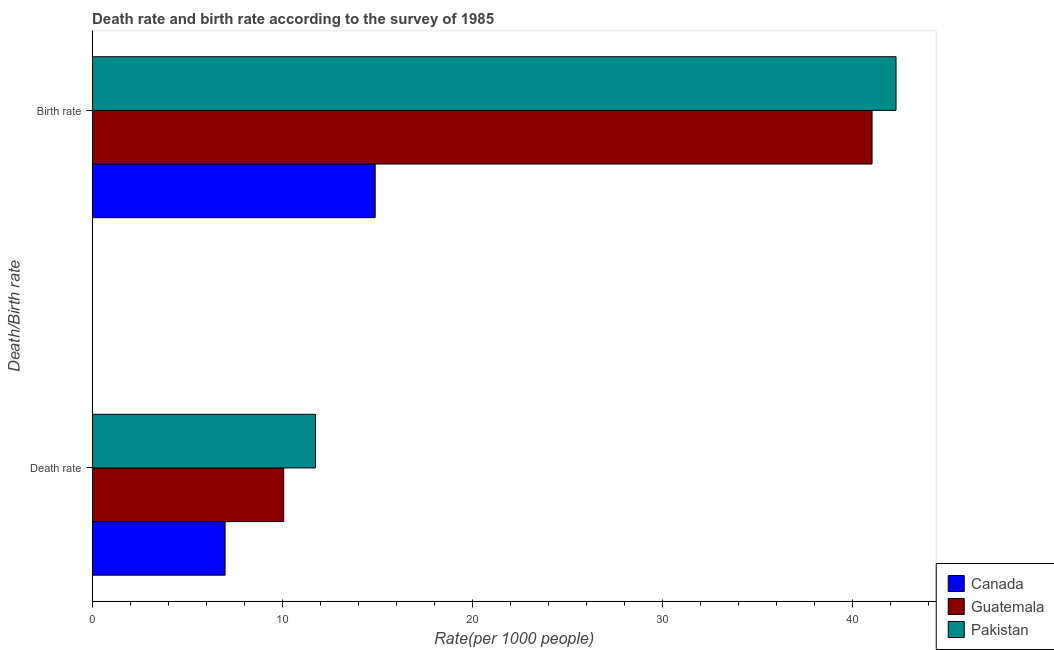How many groups of bars are there?
Keep it short and to the point. 2. Are the number of bars per tick equal to the number of legend labels?
Provide a short and direct response. Yes. Are the number of bars on each tick of the Y-axis equal?
Your answer should be compact. Yes. How many bars are there on the 2nd tick from the top?
Provide a succinct answer. 3. How many bars are there on the 2nd tick from the bottom?
Your response must be concise. 3. What is the label of the 1st group of bars from the top?
Keep it short and to the point. Birth rate. What is the death rate in Guatemala?
Ensure brevity in your answer.  10.09. Across all countries, what is the maximum death rate?
Your answer should be very brief. 11.76. Across all countries, what is the minimum birth rate?
Your response must be concise. 14.9. In which country was the death rate maximum?
Make the answer very short. Pakistan. What is the total death rate in the graph?
Your response must be concise. 28.84. What is the difference between the birth rate in Pakistan and that in Guatemala?
Your answer should be compact. 1.26. What is the difference between the death rate in Pakistan and the birth rate in Guatemala?
Give a very brief answer. -29.29. What is the average birth rate per country?
Give a very brief answer. 32.76. What is the difference between the birth rate and death rate in Pakistan?
Give a very brief answer. 30.56. In how many countries, is the death rate greater than 32 ?
Your answer should be compact. 0. What is the ratio of the birth rate in Guatemala to that in Pakistan?
Your answer should be compact. 0.97. Is the birth rate in Pakistan less than that in Guatemala?
Provide a succinct answer. No. What does the 1st bar from the bottom in Death rate represents?
Your answer should be very brief. Canada. How many bars are there?
Your answer should be compact. 6. Are all the bars in the graph horizontal?
Keep it short and to the point. Yes. What is the difference between two consecutive major ticks on the X-axis?
Give a very brief answer. 10. Are the values on the major ticks of X-axis written in scientific E-notation?
Make the answer very short. No. Does the graph contain any zero values?
Your response must be concise. No. Where does the legend appear in the graph?
Your response must be concise. Bottom right. How are the legend labels stacked?
Make the answer very short. Vertical. What is the title of the graph?
Ensure brevity in your answer.  Death rate and birth rate according to the survey of 1985. Does "Tunisia" appear as one of the legend labels in the graph?
Provide a short and direct response. No. What is the label or title of the X-axis?
Provide a succinct answer. Rate(per 1000 people). What is the label or title of the Y-axis?
Offer a terse response. Death/Birth rate. What is the Rate(per 1000 people) in Guatemala in Death rate?
Your answer should be very brief. 10.09. What is the Rate(per 1000 people) of Pakistan in Death rate?
Provide a succinct answer. 11.76. What is the Rate(per 1000 people) in Guatemala in Birth rate?
Your response must be concise. 41.05. What is the Rate(per 1000 people) in Pakistan in Birth rate?
Give a very brief answer. 42.31. Across all Death/Birth rate, what is the maximum Rate(per 1000 people) in Guatemala?
Make the answer very short. 41.05. Across all Death/Birth rate, what is the maximum Rate(per 1000 people) in Pakistan?
Provide a succinct answer. 42.31. Across all Death/Birth rate, what is the minimum Rate(per 1000 people) of Canada?
Your response must be concise. 7. Across all Death/Birth rate, what is the minimum Rate(per 1000 people) of Guatemala?
Make the answer very short. 10.09. Across all Death/Birth rate, what is the minimum Rate(per 1000 people) of Pakistan?
Provide a short and direct response. 11.76. What is the total Rate(per 1000 people) of Canada in the graph?
Your answer should be very brief. 21.9. What is the total Rate(per 1000 people) of Guatemala in the graph?
Your answer should be very brief. 51.14. What is the total Rate(per 1000 people) of Pakistan in the graph?
Offer a very short reply. 54.07. What is the difference between the Rate(per 1000 people) of Guatemala in Death rate and that in Birth rate?
Ensure brevity in your answer.  -30.97. What is the difference between the Rate(per 1000 people) of Pakistan in Death rate and that in Birth rate?
Your answer should be compact. -30.56. What is the difference between the Rate(per 1000 people) of Canada in Death rate and the Rate(per 1000 people) of Guatemala in Birth rate?
Your answer should be compact. -34.05. What is the difference between the Rate(per 1000 people) of Canada in Death rate and the Rate(per 1000 people) of Pakistan in Birth rate?
Provide a succinct answer. -35.31. What is the difference between the Rate(per 1000 people) of Guatemala in Death rate and the Rate(per 1000 people) of Pakistan in Birth rate?
Give a very brief answer. -32.23. What is the average Rate(per 1000 people) in Canada per Death/Birth rate?
Offer a terse response. 10.95. What is the average Rate(per 1000 people) in Guatemala per Death/Birth rate?
Your answer should be compact. 25.57. What is the average Rate(per 1000 people) in Pakistan per Death/Birth rate?
Give a very brief answer. 27.04. What is the difference between the Rate(per 1000 people) in Canada and Rate(per 1000 people) in Guatemala in Death rate?
Your answer should be very brief. -3.08. What is the difference between the Rate(per 1000 people) in Canada and Rate(per 1000 people) in Pakistan in Death rate?
Offer a very short reply. -4.76. What is the difference between the Rate(per 1000 people) in Guatemala and Rate(per 1000 people) in Pakistan in Death rate?
Provide a short and direct response. -1.67. What is the difference between the Rate(per 1000 people) of Canada and Rate(per 1000 people) of Guatemala in Birth rate?
Make the answer very short. -26.15. What is the difference between the Rate(per 1000 people) of Canada and Rate(per 1000 people) of Pakistan in Birth rate?
Provide a succinct answer. -27.41. What is the difference between the Rate(per 1000 people) in Guatemala and Rate(per 1000 people) in Pakistan in Birth rate?
Offer a very short reply. -1.26. What is the ratio of the Rate(per 1000 people) in Canada in Death rate to that in Birth rate?
Make the answer very short. 0.47. What is the ratio of the Rate(per 1000 people) in Guatemala in Death rate to that in Birth rate?
Ensure brevity in your answer.  0.25. What is the ratio of the Rate(per 1000 people) in Pakistan in Death rate to that in Birth rate?
Offer a terse response. 0.28. What is the difference between the highest and the second highest Rate(per 1000 people) of Canada?
Your response must be concise. 7.9. What is the difference between the highest and the second highest Rate(per 1000 people) in Guatemala?
Keep it short and to the point. 30.97. What is the difference between the highest and the second highest Rate(per 1000 people) in Pakistan?
Give a very brief answer. 30.56. What is the difference between the highest and the lowest Rate(per 1000 people) in Canada?
Your answer should be very brief. 7.9. What is the difference between the highest and the lowest Rate(per 1000 people) in Guatemala?
Ensure brevity in your answer.  30.97. What is the difference between the highest and the lowest Rate(per 1000 people) of Pakistan?
Give a very brief answer. 30.56. 